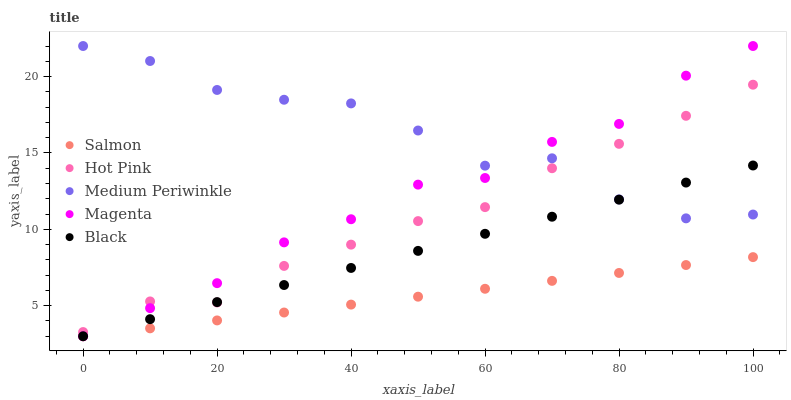Does Salmon have the minimum area under the curve?
Answer yes or no. Yes. Does Medium Periwinkle have the maximum area under the curve?
Answer yes or no. Yes. Does Magenta have the minimum area under the curve?
Answer yes or no. No. Does Magenta have the maximum area under the curve?
Answer yes or no. No. Is Black the smoothest?
Answer yes or no. Yes. Is Medium Periwinkle the roughest?
Answer yes or no. Yes. Is Magenta the smoothest?
Answer yes or no. No. Is Magenta the roughest?
Answer yes or no. No. Does Magenta have the lowest value?
Answer yes or no. Yes. Does Hot Pink have the lowest value?
Answer yes or no. No. Does Magenta have the highest value?
Answer yes or no. Yes. Does Hot Pink have the highest value?
Answer yes or no. No. Is Salmon less than Hot Pink?
Answer yes or no. Yes. Is Medium Periwinkle greater than Salmon?
Answer yes or no. Yes. Does Hot Pink intersect Magenta?
Answer yes or no. Yes. Is Hot Pink less than Magenta?
Answer yes or no. No. Is Hot Pink greater than Magenta?
Answer yes or no. No. Does Salmon intersect Hot Pink?
Answer yes or no. No. 